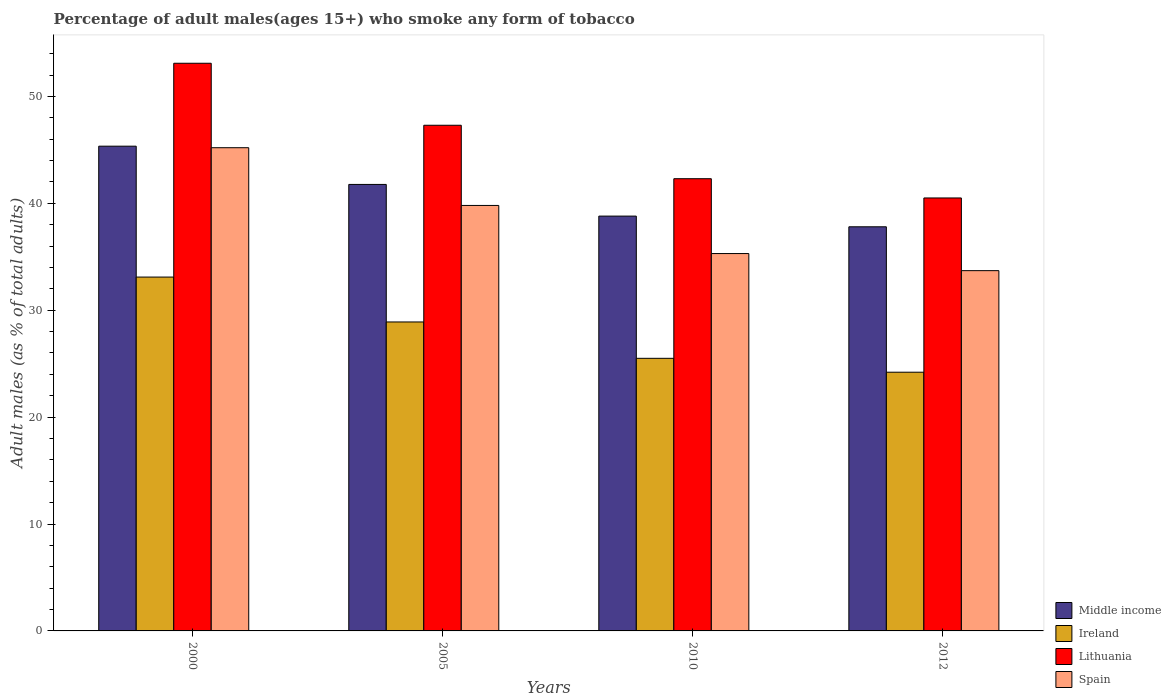How many different coloured bars are there?
Your response must be concise. 4. Are the number of bars on each tick of the X-axis equal?
Provide a succinct answer. Yes. How many bars are there on the 4th tick from the right?
Your answer should be very brief. 4. What is the label of the 2nd group of bars from the left?
Offer a terse response. 2005. In how many cases, is the number of bars for a given year not equal to the number of legend labels?
Ensure brevity in your answer.  0. What is the percentage of adult males who smoke in Spain in 2012?
Your answer should be very brief. 33.7. Across all years, what is the maximum percentage of adult males who smoke in Spain?
Your response must be concise. 45.2. Across all years, what is the minimum percentage of adult males who smoke in Ireland?
Keep it short and to the point. 24.2. In which year was the percentage of adult males who smoke in Ireland minimum?
Your response must be concise. 2012. What is the total percentage of adult males who smoke in Spain in the graph?
Give a very brief answer. 154. What is the difference between the percentage of adult males who smoke in Ireland in 2000 and that in 2005?
Make the answer very short. 4.2. What is the difference between the percentage of adult males who smoke in Lithuania in 2000 and the percentage of adult males who smoke in Ireland in 2012?
Ensure brevity in your answer.  28.9. What is the average percentage of adult males who smoke in Ireland per year?
Your response must be concise. 27.93. In the year 2000, what is the difference between the percentage of adult males who smoke in Middle income and percentage of adult males who smoke in Lithuania?
Ensure brevity in your answer.  -7.76. What is the ratio of the percentage of adult males who smoke in Spain in 2005 to that in 2010?
Your answer should be very brief. 1.13. Is the percentage of adult males who smoke in Ireland in 2000 less than that in 2010?
Make the answer very short. No. Is the difference between the percentage of adult males who smoke in Middle income in 2005 and 2010 greater than the difference between the percentage of adult males who smoke in Lithuania in 2005 and 2010?
Your answer should be compact. No. What is the difference between the highest and the second highest percentage of adult males who smoke in Ireland?
Make the answer very short. 4.2. What is the difference between the highest and the lowest percentage of adult males who smoke in Ireland?
Ensure brevity in your answer.  8.9. In how many years, is the percentage of adult males who smoke in Ireland greater than the average percentage of adult males who smoke in Ireland taken over all years?
Your answer should be compact. 2. Is the sum of the percentage of adult males who smoke in Ireland in 2005 and 2012 greater than the maximum percentage of adult males who smoke in Lithuania across all years?
Your response must be concise. No. What does the 4th bar from the left in 2010 represents?
Offer a very short reply. Spain. What does the 1st bar from the right in 2000 represents?
Offer a terse response. Spain. Are all the bars in the graph horizontal?
Keep it short and to the point. No. How many years are there in the graph?
Provide a short and direct response. 4. Are the values on the major ticks of Y-axis written in scientific E-notation?
Keep it short and to the point. No. Where does the legend appear in the graph?
Your answer should be compact. Bottom right. How many legend labels are there?
Offer a terse response. 4. What is the title of the graph?
Ensure brevity in your answer.  Percentage of adult males(ages 15+) who smoke any form of tobacco. What is the label or title of the Y-axis?
Offer a terse response. Adult males (as % of total adults). What is the Adult males (as % of total adults) of Middle income in 2000?
Keep it short and to the point. 45.34. What is the Adult males (as % of total adults) in Ireland in 2000?
Offer a terse response. 33.1. What is the Adult males (as % of total adults) of Lithuania in 2000?
Your response must be concise. 53.1. What is the Adult males (as % of total adults) in Spain in 2000?
Provide a succinct answer. 45.2. What is the Adult males (as % of total adults) in Middle income in 2005?
Provide a short and direct response. 41.77. What is the Adult males (as % of total adults) in Ireland in 2005?
Your answer should be very brief. 28.9. What is the Adult males (as % of total adults) of Lithuania in 2005?
Offer a terse response. 47.3. What is the Adult males (as % of total adults) in Spain in 2005?
Offer a very short reply. 39.8. What is the Adult males (as % of total adults) of Middle income in 2010?
Your answer should be compact. 38.8. What is the Adult males (as % of total adults) of Ireland in 2010?
Provide a succinct answer. 25.5. What is the Adult males (as % of total adults) in Lithuania in 2010?
Give a very brief answer. 42.3. What is the Adult males (as % of total adults) of Spain in 2010?
Offer a terse response. 35.3. What is the Adult males (as % of total adults) of Middle income in 2012?
Your response must be concise. 37.8. What is the Adult males (as % of total adults) of Ireland in 2012?
Ensure brevity in your answer.  24.2. What is the Adult males (as % of total adults) of Lithuania in 2012?
Offer a terse response. 40.5. What is the Adult males (as % of total adults) in Spain in 2012?
Provide a succinct answer. 33.7. Across all years, what is the maximum Adult males (as % of total adults) in Middle income?
Your response must be concise. 45.34. Across all years, what is the maximum Adult males (as % of total adults) of Ireland?
Offer a terse response. 33.1. Across all years, what is the maximum Adult males (as % of total adults) of Lithuania?
Ensure brevity in your answer.  53.1. Across all years, what is the maximum Adult males (as % of total adults) in Spain?
Provide a succinct answer. 45.2. Across all years, what is the minimum Adult males (as % of total adults) in Middle income?
Offer a very short reply. 37.8. Across all years, what is the minimum Adult males (as % of total adults) in Ireland?
Your answer should be very brief. 24.2. Across all years, what is the minimum Adult males (as % of total adults) in Lithuania?
Give a very brief answer. 40.5. Across all years, what is the minimum Adult males (as % of total adults) in Spain?
Your answer should be very brief. 33.7. What is the total Adult males (as % of total adults) in Middle income in the graph?
Your response must be concise. 163.71. What is the total Adult males (as % of total adults) in Ireland in the graph?
Your answer should be compact. 111.7. What is the total Adult males (as % of total adults) of Lithuania in the graph?
Your answer should be very brief. 183.2. What is the total Adult males (as % of total adults) of Spain in the graph?
Keep it short and to the point. 154. What is the difference between the Adult males (as % of total adults) of Middle income in 2000 and that in 2005?
Provide a short and direct response. 3.58. What is the difference between the Adult males (as % of total adults) of Middle income in 2000 and that in 2010?
Give a very brief answer. 6.54. What is the difference between the Adult males (as % of total adults) of Ireland in 2000 and that in 2010?
Offer a very short reply. 7.6. What is the difference between the Adult males (as % of total adults) in Lithuania in 2000 and that in 2010?
Your answer should be compact. 10.8. What is the difference between the Adult males (as % of total adults) of Spain in 2000 and that in 2010?
Keep it short and to the point. 9.9. What is the difference between the Adult males (as % of total adults) in Middle income in 2000 and that in 2012?
Give a very brief answer. 7.54. What is the difference between the Adult males (as % of total adults) of Lithuania in 2000 and that in 2012?
Provide a short and direct response. 12.6. What is the difference between the Adult males (as % of total adults) in Spain in 2000 and that in 2012?
Provide a short and direct response. 11.5. What is the difference between the Adult males (as % of total adults) of Middle income in 2005 and that in 2010?
Your response must be concise. 2.96. What is the difference between the Adult males (as % of total adults) in Ireland in 2005 and that in 2010?
Offer a terse response. 3.4. What is the difference between the Adult males (as % of total adults) in Lithuania in 2005 and that in 2010?
Offer a very short reply. 5. What is the difference between the Adult males (as % of total adults) of Middle income in 2005 and that in 2012?
Offer a terse response. 3.96. What is the difference between the Adult males (as % of total adults) in Middle income in 2000 and the Adult males (as % of total adults) in Ireland in 2005?
Make the answer very short. 16.44. What is the difference between the Adult males (as % of total adults) in Middle income in 2000 and the Adult males (as % of total adults) in Lithuania in 2005?
Give a very brief answer. -1.96. What is the difference between the Adult males (as % of total adults) of Middle income in 2000 and the Adult males (as % of total adults) of Spain in 2005?
Your answer should be compact. 5.54. What is the difference between the Adult males (as % of total adults) in Middle income in 2000 and the Adult males (as % of total adults) in Ireland in 2010?
Provide a succinct answer. 19.84. What is the difference between the Adult males (as % of total adults) in Middle income in 2000 and the Adult males (as % of total adults) in Lithuania in 2010?
Provide a short and direct response. 3.04. What is the difference between the Adult males (as % of total adults) of Middle income in 2000 and the Adult males (as % of total adults) of Spain in 2010?
Offer a very short reply. 10.04. What is the difference between the Adult males (as % of total adults) of Ireland in 2000 and the Adult males (as % of total adults) of Lithuania in 2010?
Offer a very short reply. -9.2. What is the difference between the Adult males (as % of total adults) of Middle income in 2000 and the Adult males (as % of total adults) of Ireland in 2012?
Offer a terse response. 21.14. What is the difference between the Adult males (as % of total adults) of Middle income in 2000 and the Adult males (as % of total adults) of Lithuania in 2012?
Offer a terse response. 4.84. What is the difference between the Adult males (as % of total adults) of Middle income in 2000 and the Adult males (as % of total adults) of Spain in 2012?
Keep it short and to the point. 11.64. What is the difference between the Adult males (as % of total adults) of Ireland in 2000 and the Adult males (as % of total adults) of Spain in 2012?
Ensure brevity in your answer.  -0.6. What is the difference between the Adult males (as % of total adults) of Middle income in 2005 and the Adult males (as % of total adults) of Ireland in 2010?
Offer a very short reply. 16.27. What is the difference between the Adult males (as % of total adults) in Middle income in 2005 and the Adult males (as % of total adults) in Lithuania in 2010?
Your answer should be compact. -0.53. What is the difference between the Adult males (as % of total adults) in Middle income in 2005 and the Adult males (as % of total adults) in Spain in 2010?
Offer a very short reply. 6.47. What is the difference between the Adult males (as % of total adults) in Ireland in 2005 and the Adult males (as % of total adults) in Lithuania in 2010?
Your response must be concise. -13.4. What is the difference between the Adult males (as % of total adults) of Lithuania in 2005 and the Adult males (as % of total adults) of Spain in 2010?
Your response must be concise. 12. What is the difference between the Adult males (as % of total adults) of Middle income in 2005 and the Adult males (as % of total adults) of Ireland in 2012?
Give a very brief answer. 17.57. What is the difference between the Adult males (as % of total adults) in Middle income in 2005 and the Adult males (as % of total adults) in Lithuania in 2012?
Provide a succinct answer. 1.27. What is the difference between the Adult males (as % of total adults) in Middle income in 2005 and the Adult males (as % of total adults) in Spain in 2012?
Offer a terse response. 8.07. What is the difference between the Adult males (as % of total adults) of Ireland in 2005 and the Adult males (as % of total adults) of Spain in 2012?
Offer a terse response. -4.8. What is the difference between the Adult males (as % of total adults) in Middle income in 2010 and the Adult males (as % of total adults) in Ireland in 2012?
Offer a terse response. 14.6. What is the difference between the Adult males (as % of total adults) in Middle income in 2010 and the Adult males (as % of total adults) in Lithuania in 2012?
Provide a short and direct response. -1.7. What is the difference between the Adult males (as % of total adults) of Middle income in 2010 and the Adult males (as % of total adults) of Spain in 2012?
Offer a very short reply. 5.1. What is the difference between the Adult males (as % of total adults) of Ireland in 2010 and the Adult males (as % of total adults) of Lithuania in 2012?
Your answer should be compact. -15. What is the average Adult males (as % of total adults) of Middle income per year?
Ensure brevity in your answer.  40.93. What is the average Adult males (as % of total adults) of Ireland per year?
Your response must be concise. 27.93. What is the average Adult males (as % of total adults) of Lithuania per year?
Provide a succinct answer. 45.8. What is the average Adult males (as % of total adults) in Spain per year?
Keep it short and to the point. 38.5. In the year 2000, what is the difference between the Adult males (as % of total adults) in Middle income and Adult males (as % of total adults) in Ireland?
Your answer should be very brief. 12.24. In the year 2000, what is the difference between the Adult males (as % of total adults) of Middle income and Adult males (as % of total adults) of Lithuania?
Offer a terse response. -7.76. In the year 2000, what is the difference between the Adult males (as % of total adults) in Middle income and Adult males (as % of total adults) in Spain?
Offer a very short reply. 0.14. In the year 2000, what is the difference between the Adult males (as % of total adults) in Ireland and Adult males (as % of total adults) in Lithuania?
Give a very brief answer. -20. In the year 2000, what is the difference between the Adult males (as % of total adults) in Ireland and Adult males (as % of total adults) in Spain?
Ensure brevity in your answer.  -12.1. In the year 2005, what is the difference between the Adult males (as % of total adults) in Middle income and Adult males (as % of total adults) in Ireland?
Your answer should be compact. 12.87. In the year 2005, what is the difference between the Adult males (as % of total adults) in Middle income and Adult males (as % of total adults) in Lithuania?
Keep it short and to the point. -5.53. In the year 2005, what is the difference between the Adult males (as % of total adults) of Middle income and Adult males (as % of total adults) of Spain?
Ensure brevity in your answer.  1.97. In the year 2005, what is the difference between the Adult males (as % of total adults) of Ireland and Adult males (as % of total adults) of Lithuania?
Provide a short and direct response. -18.4. In the year 2005, what is the difference between the Adult males (as % of total adults) of Ireland and Adult males (as % of total adults) of Spain?
Your response must be concise. -10.9. In the year 2010, what is the difference between the Adult males (as % of total adults) of Middle income and Adult males (as % of total adults) of Ireland?
Offer a very short reply. 13.3. In the year 2010, what is the difference between the Adult males (as % of total adults) of Middle income and Adult males (as % of total adults) of Lithuania?
Your response must be concise. -3.5. In the year 2010, what is the difference between the Adult males (as % of total adults) of Middle income and Adult males (as % of total adults) of Spain?
Provide a short and direct response. 3.5. In the year 2010, what is the difference between the Adult males (as % of total adults) in Ireland and Adult males (as % of total adults) in Lithuania?
Make the answer very short. -16.8. In the year 2010, what is the difference between the Adult males (as % of total adults) of Ireland and Adult males (as % of total adults) of Spain?
Provide a short and direct response. -9.8. In the year 2012, what is the difference between the Adult males (as % of total adults) in Middle income and Adult males (as % of total adults) in Ireland?
Keep it short and to the point. 13.6. In the year 2012, what is the difference between the Adult males (as % of total adults) in Middle income and Adult males (as % of total adults) in Lithuania?
Offer a very short reply. -2.7. In the year 2012, what is the difference between the Adult males (as % of total adults) in Middle income and Adult males (as % of total adults) in Spain?
Your answer should be very brief. 4.1. In the year 2012, what is the difference between the Adult males (as % of total adults) in Ireland and Adult males (as % of total adults) in Lithuania?
Ensure brevity in your answer.  -16.3. In the year 2012, what is the difference between the Adult males (as % of total adults) of Lithuania and Adult males (as % of total adults) of Spain?
Your response must be concise. 6.8. What is the ratio of the Adult males (as % of total adults) in Middle income in 2000 to that in 2005?
Give a very brief answer. 1.09. What is the ratio of the Adult males (as % of total adults) of Ireland in 2000 to that in 2005?
Offer a very short reply. 1.15. What is the ratio of the Adult males (as % of total adults) in Lithuania in 2000 to that in 2005?
Make the answer very short. 1.12. What is the ratio of the Adult males (as % of total adults) of Spain in 2000 to that in 2005?
Offer a very short reply. 1.14. What is the ratio of the Adult males (as % of total adults) in Middle income in 2000 to that in 2010?
Make the answer very short. 1.17. What is the ratio of the Adult males (as % of total adults) of Ireland in 2000 to that in 2010?
Your answer should be very brief. 1.3. What is the ratio of the Adult males (as % of total adults) of Lithuania in 2000 to that in 2010?
Provide a succinct answer. 1.26. What is the ratio of the Adult males (as % of total adults) in Spain in 2000 to that in 2010?
Your response must be concise. 1.28. What is the ratio of the Adult males (as % of total adults) in Middle income in 2000 to that in 2012?
Your answer should be very brief. 1.2. What is the ratio of the Adult males (as % of total adults) in Ireland in 2000 to that in 2012?
Offer a terse response. 1.37. What is the ratio of the Adult males (as % of total adults) of Lithuania in 2000 to that in 2012?
Ensure brevity in your answer.  1.31. What is the ratio of the Adult males (as % of total adults) of Spain in 2000 to that in 2012?
Your answer should be compact. 1.34. What is the ratio of the Adult males (as % of total adults) in Middle income in 2005 to that in 2010?
Give a very brief answer. 1.08. What is the ratio of the Adult males (as % of total adults) of Ireland in 2005 to that in 2010?
Your answer should be compact. 1.13. What is the ratio of the Adult males (as % of total adults) of Lithuania in 2005 to that in 2010?
Your answer should be very brief. 1.12. What is the ratio of the Adult males (as % of total adults) of Spain in 2005 to that in 2010?
Ensure brevity in your answer.  1.13. What is the ratio of the Adult males (as % of total adults) of Middle income in 2005 to that in 2012?
Provide a short and direct response. 1.1. What is the ratio of the Adult males (as % of total adults) of Ireland in 2005 to that in 2012?
Give a very brief answer. 1.19. What is the ratio of the Adult males (as % of total adults) of Lithuania in 2005 to that in 2012?
Ensure brevity in your answer.  1.17. What is the ratio of the Adult males (as % of total adults) in Spain in 2005 to that in 2012?
Offer a terse response. 1.18. What is the ratio of the Adult males (as % of total adults) in Middle income in 2010 to that in 2012?
Your answer should be very brief. 1.03. What is the ratio of the Adult males (as % of total adults) in Ireland in 2010 to that in 2012?
Ensure brevity in your answer.  1.05. What is the ratio of the Adult males (as % of total adults) in Lithuania in 2010 to that in 2012?
Keep it short and to the point. 1.04. What is the ratio of the Adult males (as % of total adults) in Spain in 2010 to that in 2012?
Ensure brevity in your answer.  1.05. What is the difference between the highest and the second highest Adult males (as % of total adults) of Middle income?
Provide a succinct answer. 3.58. What is the difference between the highest and the second highest Adult males (as % of total adults) of Ireland?
Give a very brief answer. 4.2. What is the difference between the highest and the second highest Adult males (as % of total adults) in Lithuania?
Offer a terse response. 5.8. What is the difference between the highest and the second highest Adult males (as % of total adults) of Spain?
Keep it short and to the point. 5.4. What is the difference between the highest and the lowest Adult males (as % of total adults) in Middle income?
Your answer should be compact. 7.54. What is the difference between the highest and the lowest Adult males (as % of total adults) in Spain?
Your answer should be very brief. 11.5. 